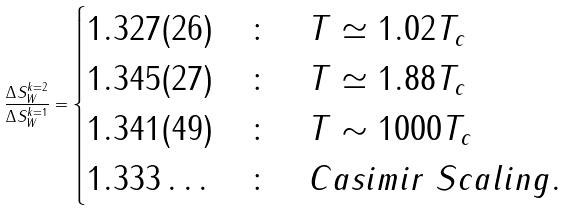Convert formula to latex. <formula><loc_0><loc_0><loc_500><loc_500>\frac { \Delta S ^ { k = 2 } _ { W } } { \Delta S ^ { k = 1 } _ { W } } = \begin{cases} 1 . 3 2 7 ( 2 6 ) & \colon \quad T \simeq 1 . 0 2 T _ { c } \\ 1 . 3 4 5 ( 2 7 ) & \colon \quad T \simeq 1 . 8 8 T _ { c } \\ 1 . 3 4 1 ( 4 9 ) & \colon \quad T \sim 1 0 0 0 T _ { c } \\ 1 . 3 3 3 \dots & \colon \quad C a s i m i r \ S c a l i n g . \end{cases}</formula> 